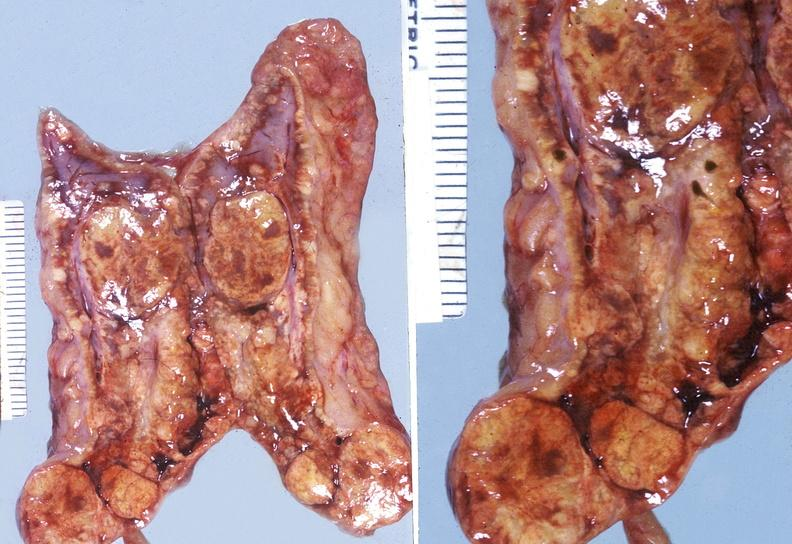does this image show adrenal, cortical adenoma?
Answer the question using a single word or phrase. Yes 